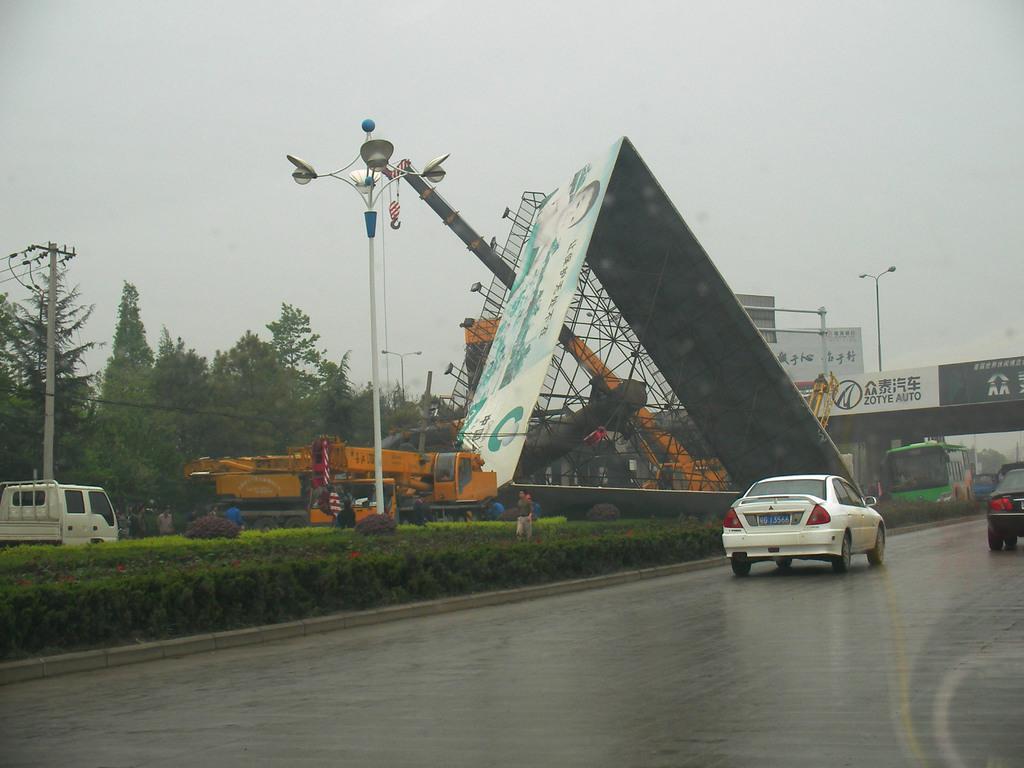Could you give a brief overview of what you see in this image? In this image there are vehicles moving on a road, in the middle there are plants and poles, in the background there are trees, hoardings and the sky. 